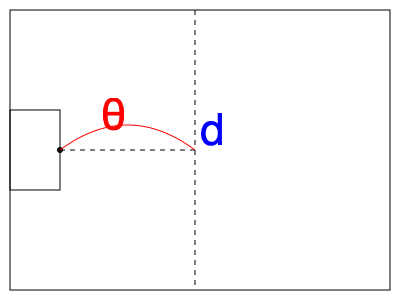A soccer player is preparing for a free kick from a distance $d$ meters away from the goal line. The optimal trajectory for the ball is a parabolic path. Given that the acceleration due to gravity $g = 9.8 \text{ m/s}^2$, determine the optimal angle $\theta$ (in degrees) for the kick to reach the maximum height at the goal line. Assume air resistance is negligible. To find the optimal angle for the free kick, we'll follow these steps:

1) In projectile motion, the maximum height is reached at half the total horizontal distance traveled. For a free kick to reach its peak at the goal line, the total horizontal distance should be $2d$.

2) The time taken for the ball to reach its highest point is half the total time of flight. Let's call this time $t$.

3) For the vertical motion:
   Initial vertical velocity: $v_y = v \sin\theta$
   At the highest point: $v_y = 0$
   Using $v = u + at$: $0 = v\sin\theta - gt$
   Therefore, $t = \frac{v\sin\theta}{g}$

4) For the horizontal motion:
   Horizontal velocity: $v_x = v \cos\theta$ (constant)
   Distance covered: $d = v_x \cdot t = v\cos\theta \cdot \frac{v\sin\theta}{g}$

5) Simplify: $d = \frac{v^2\sin\theta\cos\theta}{g} = \frac{v^2\sin(2\theta)}{2g}$

6) We want to maximize this distance. The maximum value of $\sin(2\theta)$ is 1, which occurs when $2\theta = 90°$ or $\theta = 45°$.

Therefore, the optimal angle for the free kick to reach its maximum height at the goal line is 45°.
Answer: 45° 